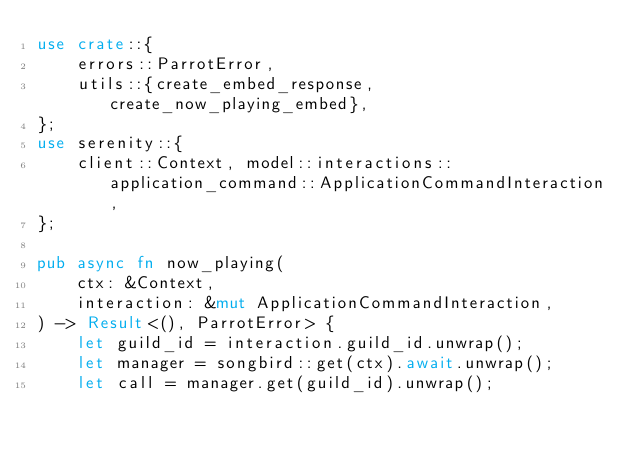Convert code to text. <code><loc_0><loc_0><loc_500><loc_500><_Rust_>use crate::{
    errors::ParrotError,
    utils::{create_embed_response, create_now_playing_embed},
};
use serenity::{
    client::Context, model::interactions::application_command::ApplicationCommandInteraction,
};

pub async fn now_playing(
    ctx: &Context,
    interaction: &mut ApplicationCommandInteraction,
) -> Result<(), ParrotError> {
    let guild_id = interaction.guild_id.unwrap();
    let manager = songbird::get(ctx).await.unwrap();
    let call = manager.get(guild_id).unwrap();
</code> 